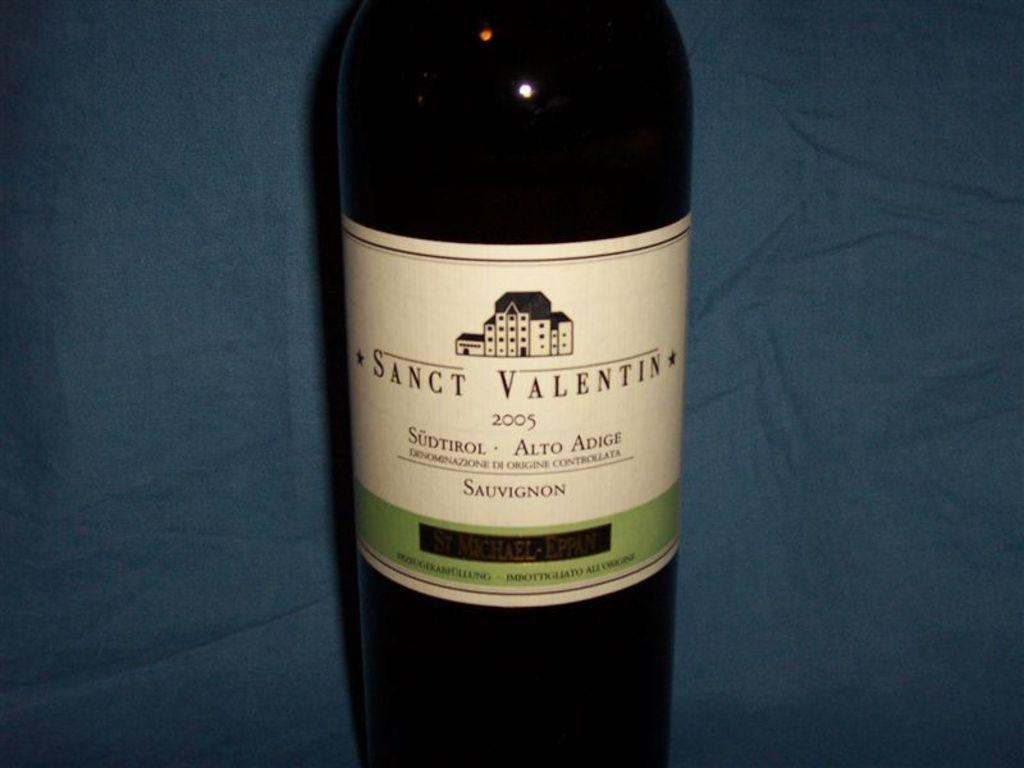Provide a one-sentence caption for the provided image. A bottle of Sanct Valentin from 2005 with a white label. 